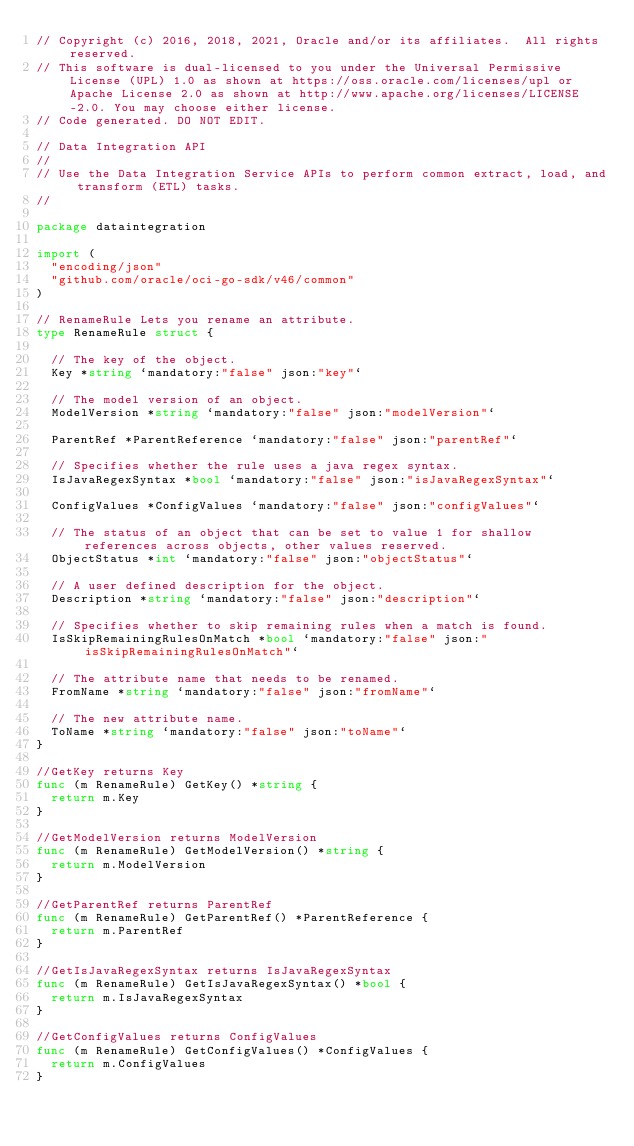Convert code to text. <code><loc_0><loc_0><loc_500><loc_500><_Go_>// Copyright (c) 2016, 2018, 2021, Oracle and/or its affiliates.  All rights reserved.
// This software is dual-licensed to you under the Universal Permissive License (UPL) 1.0 as shown at https://oss.oracle.com/licenses/upl or Apache License 2.0 as shown at http://www.apache.org/licenses/LICENSE-2.0. You may choose either license.
// Code generated. DO NOT EDIT.

// Data Integration API
//
// Use the Data Integration Service APIs to perform common extract, load, and transform (ETL) tasks.
//

package dataintegration

import (
	"encoding/json"
	"github.com/oracle/oci-go-sdk/v46/common"
)

// RenameRule Lets you rename an attribute.
type RenameRule struct {

	// The key of the object.
	Key *string `mandatory:"false" json:"key"`

	// The model version of an object.
	ModelVersion *string `mandatory:"false" json:"modelVersion"`

	ParentRef *ParentReference `mandatory:"false" json:"parentRef"`

	// Specifies whether the rule uses a java regex syntax.
	IsJavaRegexSyntax *bool `mandatory:"false" json:"isJavaRegexSyntax"`

	ConfigValues *ConfigValues `mandatory:"false" json:"configValues"`

	// The status of an object that can be set to value 1 for shallow references across objects, other values reserved.
	ObjectStatus *int `mandatory:"false" json:"objectStatus"`

	// A user defined description for the object.
	Description *string `mandatory:"false" json:"description"`

	// Specifies whether to skip remaining rules when a match is found.
	IsSkipRemainingRulesOnMatch *bool `mandatory:"false" json:"isSkipRemainingRulesOnMatch"`

	// The attribute name that needs to be renamed.
	FromName *string `mandatory:"false" json:"fromName"`

	// The new attribute name.
	ToName *string `mandatory:"false" json:"toName"`
}

//GetKey returns Key
func (m RenameRule) GetKey() *string {
	return m.Key
}

//GetModelVersion returns ModelVersion
func (m RenameRule) GetModelVersion() *string {
	return m.ModelVersion
}

//GetParentRef returns ParentRef
func (m RenameRule) GetParentRef() *ParentReference {
	return m.ParentRef
}

//GetIsJavaRegexSyntax returns IsJavaRegexSyntax
func (m RenameRule) GetIsJavaRegexSyntax() *bool {
	return m.IsJavaRegexSyntax
}

//GetConfigValues returns ConfigValues
func (m RenameRule) GetConfigValues() *ConfigValues {
	return m.ConfigValues
}
</code> 